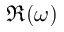<formula> <loc_0><loc_0><loc_500><loc_500>\Re ( \omega )</formula> 